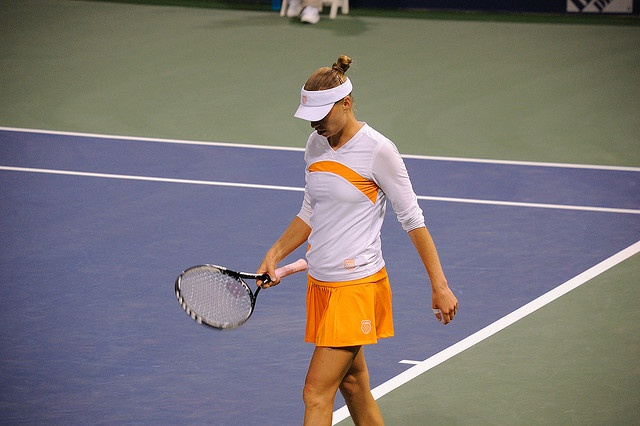Describe the objects in this image and their specific colors. I can see people in black, lavender, orange, red, and darkgray tones and tennis racket in black, darkgray, and gray tones in this image. 